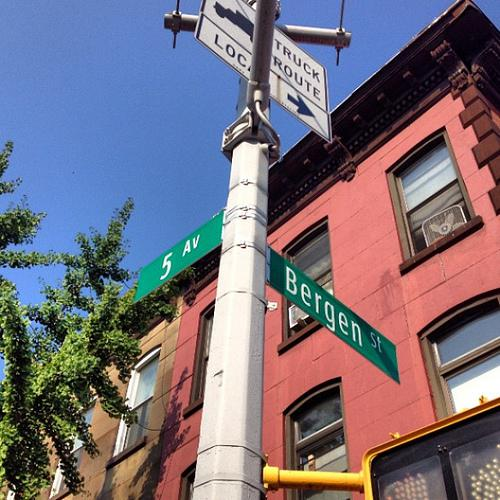Question: where is the traffic signal?
Choices:
A. Above intersection.
B. At the corner.
C. Below the green signs.
D. On both sides of road.
Answer with the letter. Answer: C Question: where is the tree?
Choices:
A. On the right.
B. In the yard.
C. In the jungle.
D. On the left.
Answer with the letter. Answer: D Question: how many green signs are there?
Choices:
A. 2.
B. 3.
C. 1.
D. 4.
Answer with the letter. Answer: A Question: what are the cross streets?
Choices:
A. Willys and Berdan.
B. Fulton and Boston.
C. Dunbar and Gloff.
D. 5 Av and Bergen St.
Answer with the letter. Answer: D Question: where is the 5 Av sign?
Choices:
A. Below the Bergen sign.
B. On the corner.
C. To the right of the Bergen sign.
D. Above the Bergen sign.
Answer with the letter. Answer: D Question: where is truck route sign?
Choices:
A. To the right of the green signs.
B. Above the green signs.
C. Under the green signs.
D. To the left of the green signs.
Answer with the letter. Answer: B Question: how many signs have arrows?
Choices:
A. Two.
B. None.
C. Three.
D. 1.
Answer with the letter. Answer: D 